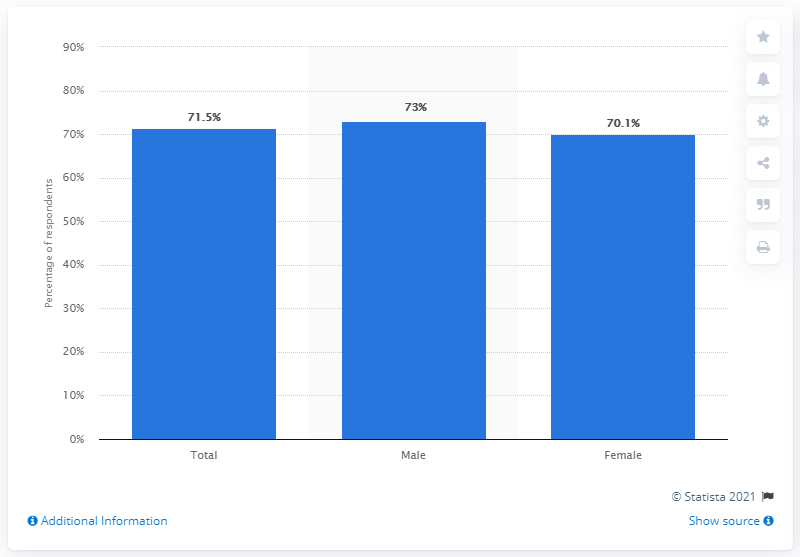Identify some key points in this picture. During the survey period, 70.1% of female internet users accessed location-based services. 